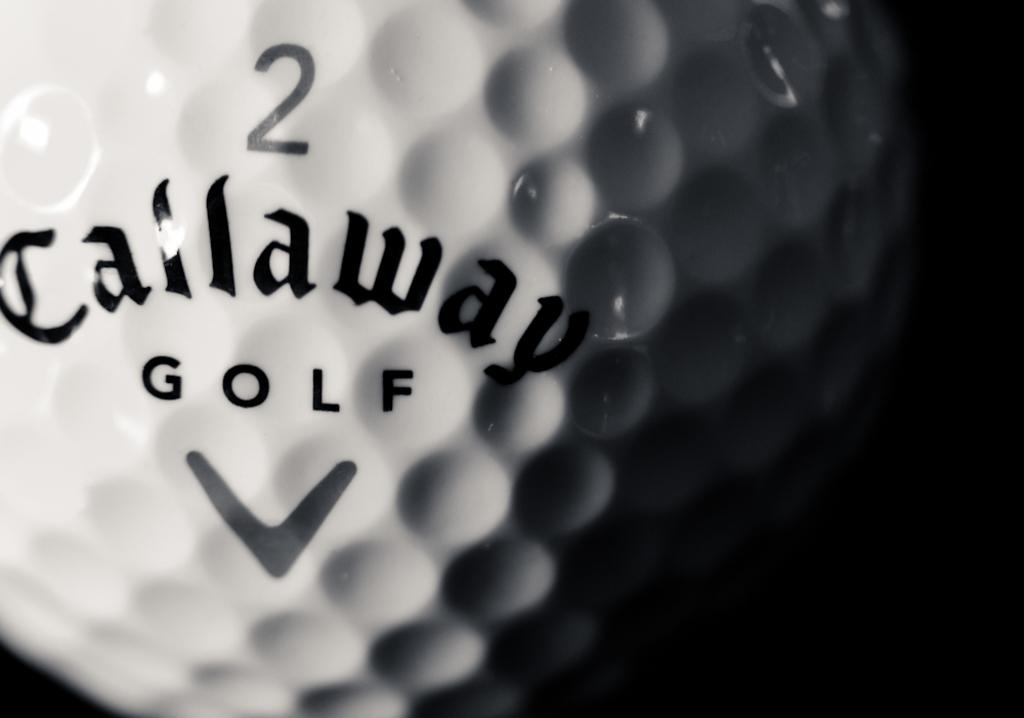What object is the main focus of the image? The main focus of the image is a golf ball. Are there any markings or text on the golf ball? Yes, there is text on the golf ball. What can be observed about the overall appearance of the image? The background of the image is dark. How many pancakes are stacked on top of the golf ball in the image? There are no pancakes present in the image; it features a golf ball with text on it. What type of pin is used to hold the golf ball in place in the image? There is no pin present in the image; the golf ball is simply visible on its own. 